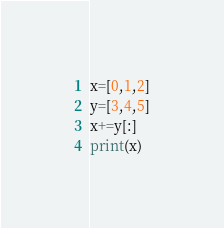Convert code to text. <code><loc_0><loc_0><loc_500><loc_500><_Python_>x=[0,1,2]
y=[3,4,5]
x+=y[:]
print(x)</code> 